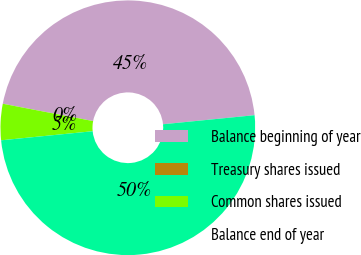<chart> <loc_0><loc_0><loc_500><loc_500><pie_chart><fcel>Balance beginning of year<fcel>Treasury shares issued<fcel>Common shares issued<fcel>Balance end of year<nl><fcel>45.41%<fcel>0.0%<fcel>4.59%<fcel>50.0%<nl></chart> 